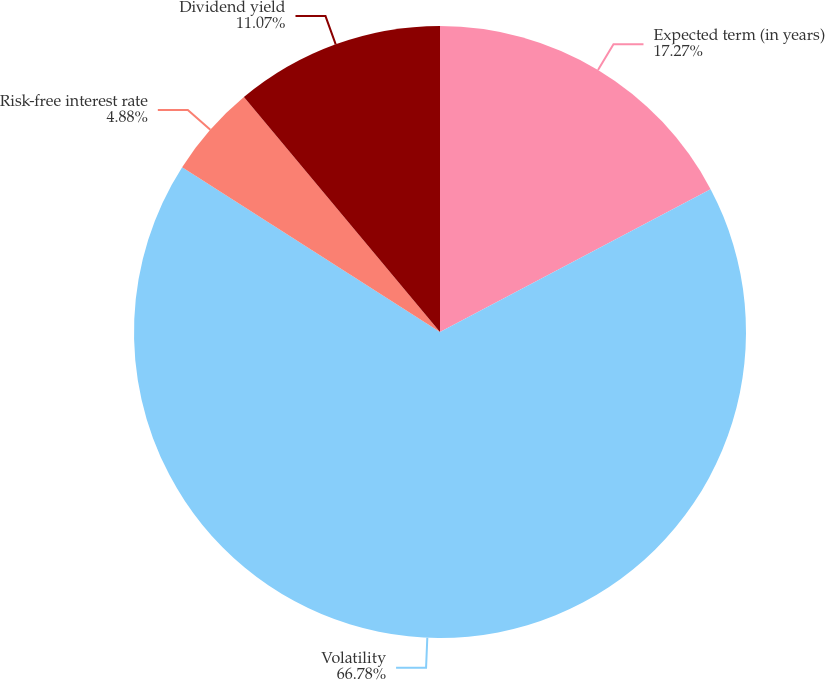<chart> <loc_0><loc_0><loc_500><loc_500><pie_chart><fcel>Expected term (in years)<fcel>Volatility<fcel>Risk-free interest rate<fcel>Dividend yield<nl><fcel>17.27%<fcel>66.78%<fcel>4.88%<fcel>11.07%<nl></chart> 